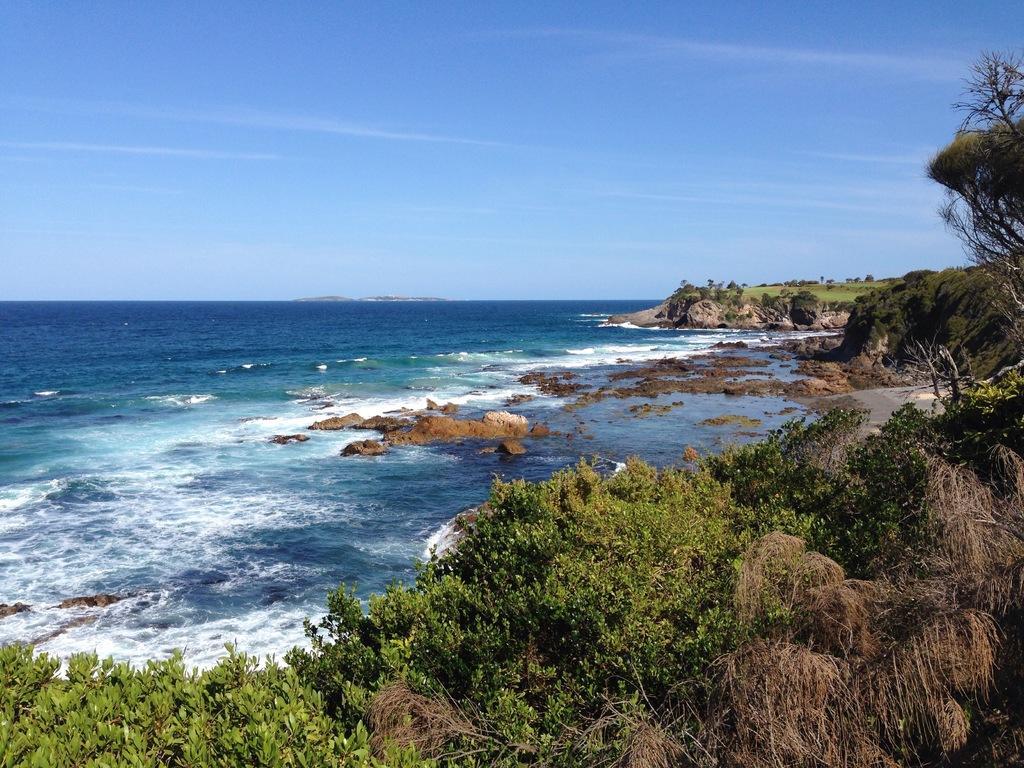Describe this image in one or two sentences. In this image there is water having few rocks. Bottom of the image there are few trees. Right side there is grassland having few rocks and trees. Top of the image there is sky. 